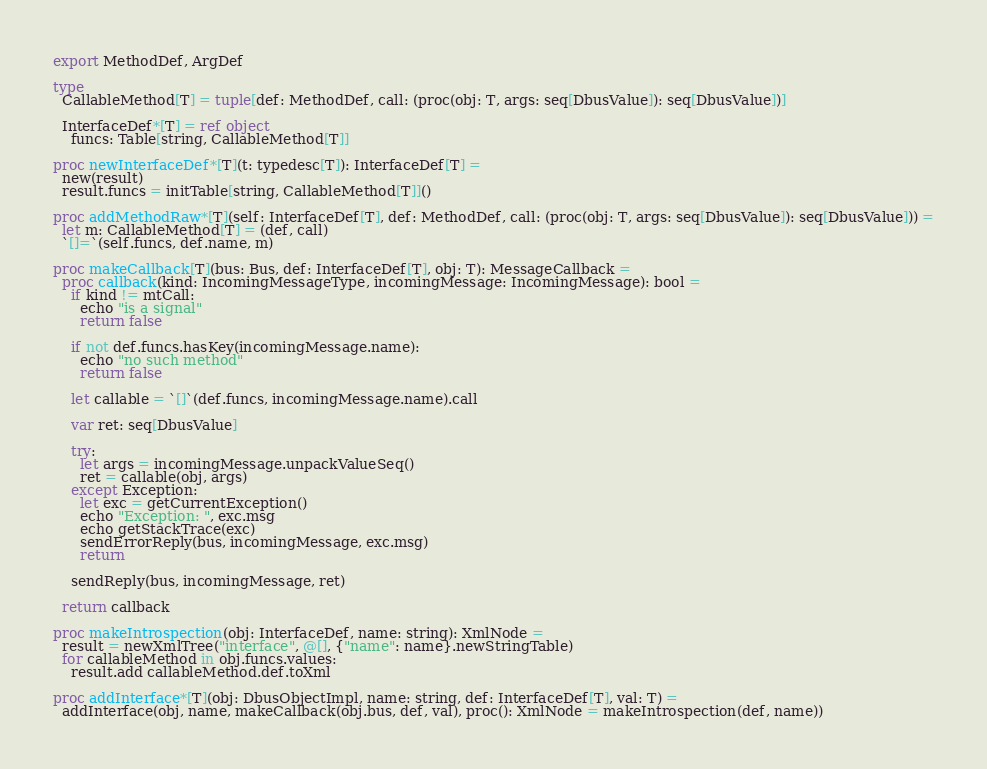Convert code to text. <code><loc_0><loc_0><loc_500><loc_500><_Nim_>
export MethodDef, ArgDef

type
  CallableMethod[T] = tuple[def: MethodDef, call: (proc(obj: T, args: seq[DbusValue]): seq[DbusValue])]

  InterfaceDef*[T] = ref object
    funcs: Table[string, CallableMethod[T]]

proc newInterfaceDef*[T](t: typedesc[T]): InterfaceDef[T] =
  new(result)
  result.funcs = initTable[string, CallableMethod[T]]()

proc addMethodRaw*[T](self: InterfaceDef[T], def: MethodDef, call: (proc(obj: T, args: seq[DbusValue]): seq[DbusValue])) =
  let m: CallableMethod[T] = (def, call)
  `[]=`(self.funcs, def.name, m)

proc makeCallback[T](bus: Bus, def: InterfaceDef[T], obj: T): MessageCallback =
  proc callback(kind: IncomingMessageType, incomingMessage: IncomingMessage): bool =
    if kind != mtCall:
      echo "is a signal"
      return false

    if not def.funcs.hasKey(incomingMessage.name):
      echo "no such method"
      return false

    let callable = `[]`(def.funcs, incomingMessage.name).call

    var ret: seq[DbusValue]

    try:
      let args = incomingMessage.unpackValueSeq()
      ret = callable(obj, args)
    except Exception:
      let exc = getCurrentException()
      echo "Exception: ", exc.msg
      echo getStackTrace(exc)
      sendErrorReply(bus, incomingMessage, exc.msg)
      return

    sendReply(bus, incomingMessage, ret)

  return callback

proc makeIntrospection(obj: InterfaceDef, name: string): XmlNode =
  result = newXmlTree("interface", @[], {"name": name}.newStringTable)
  for callableMethod in obj.funcs.values:
    result.add callableMethod.def.toXml

proc addInterface*[T](obj: DbusObjectImpl, name: string, def: InterfaceDef[T], val: T) =
  addInterface(obj, name, makeCallback(obj.bus, def, val), proc(): XmlNode = makeIntrospection(def, name))
</code> 